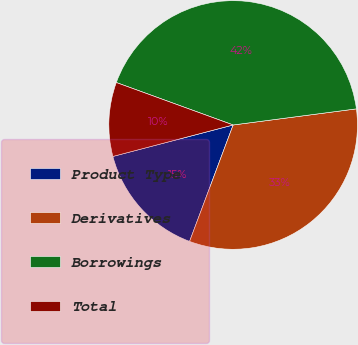Convert chart to OTSL. <chart><loc_0><loc_0><loc_500><loc_500><pie_chart><fcel>Product Type<fcel>Derivatives<fcel>Borrowings<fcel>Total<nl><fcel>15.23%<fcel>32.77%<fcel>42.39%<fcel>9.62%<nl></chart> 